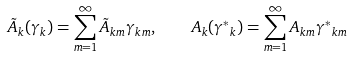Convert formula to latex. <formula><loc_0><loc_0><loc_500><loc_500>\tilde { A } _ { k } ( \gamma _ { k } ) = \sum _ { m = 1 } ^ { \infty } \tilde { A } _ { k m } \gamma _ { k m } , \quad A _ { k } ( { \gamma ^ { * } } _ { k } ) = \sum _ { m = 1 } ^ { \infty } { A } _ { k m } { \gamma ^ { * } } _ { k m }</formula> 